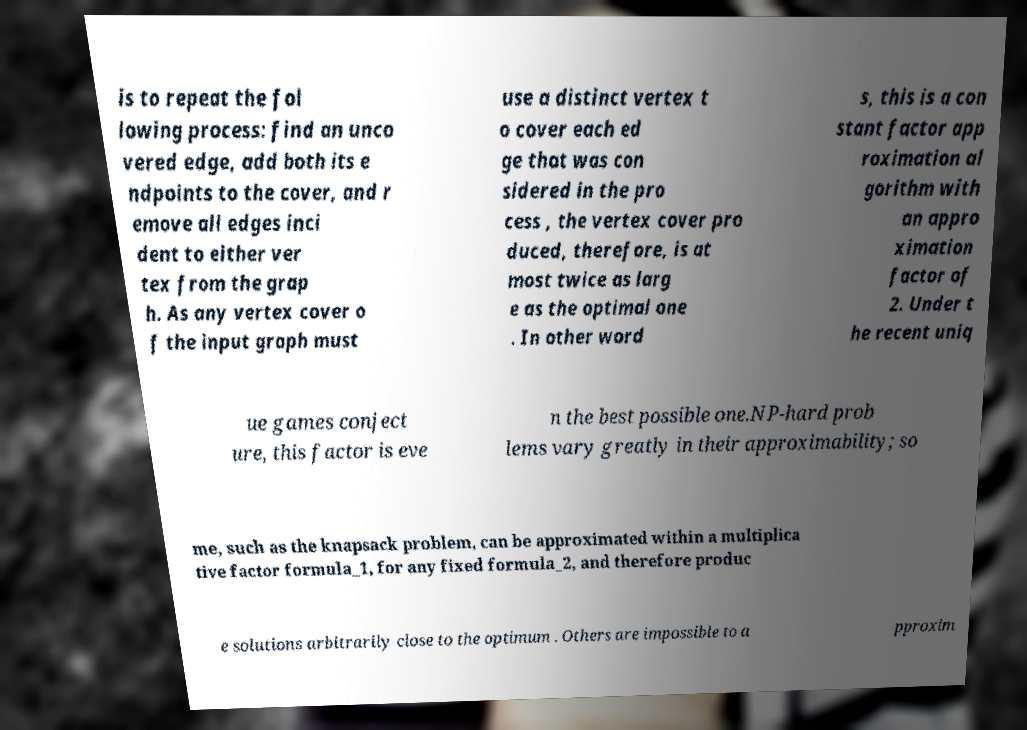Could you assist in decoding the text presented in this image and type it out clearly? is to repeat the fol lowing process: find an unco vered edge, add both its e ndpoints to the cover, and r emove all edges inci dent to either ver tex from the grap h. As any vertex cover o f the input graph must use a distinct vertex t o cover each ed ge that was con sidered in the pro cess , the vertex cover pro duced, therefore, is at most twice as larg e as the optimal one . In other word s, this is a con stant factor app roximation al gorithm with an appro ximation factor of 2. Under t he recent uniq ue games conject ure, this factor is eve n the best possible one.NP-hard prob lems vary greatly in their approximability; so me, such as the knapsack problem, can be approximated within a multiplica tive factor formula_1, for any fixed formula_2, and therefore produc e solutions arbitrarily close to the optimum . Others are impossible to a pproxim 